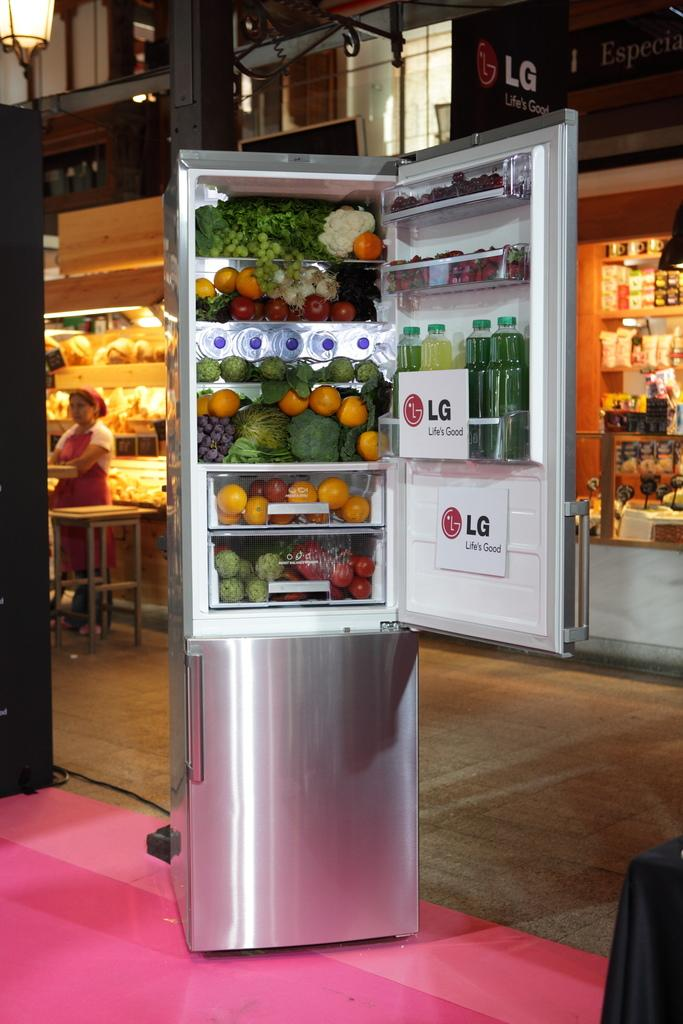<image>
Describe the image concisely. an open refrigerator with signs inside of it that say 'lg life is good' 